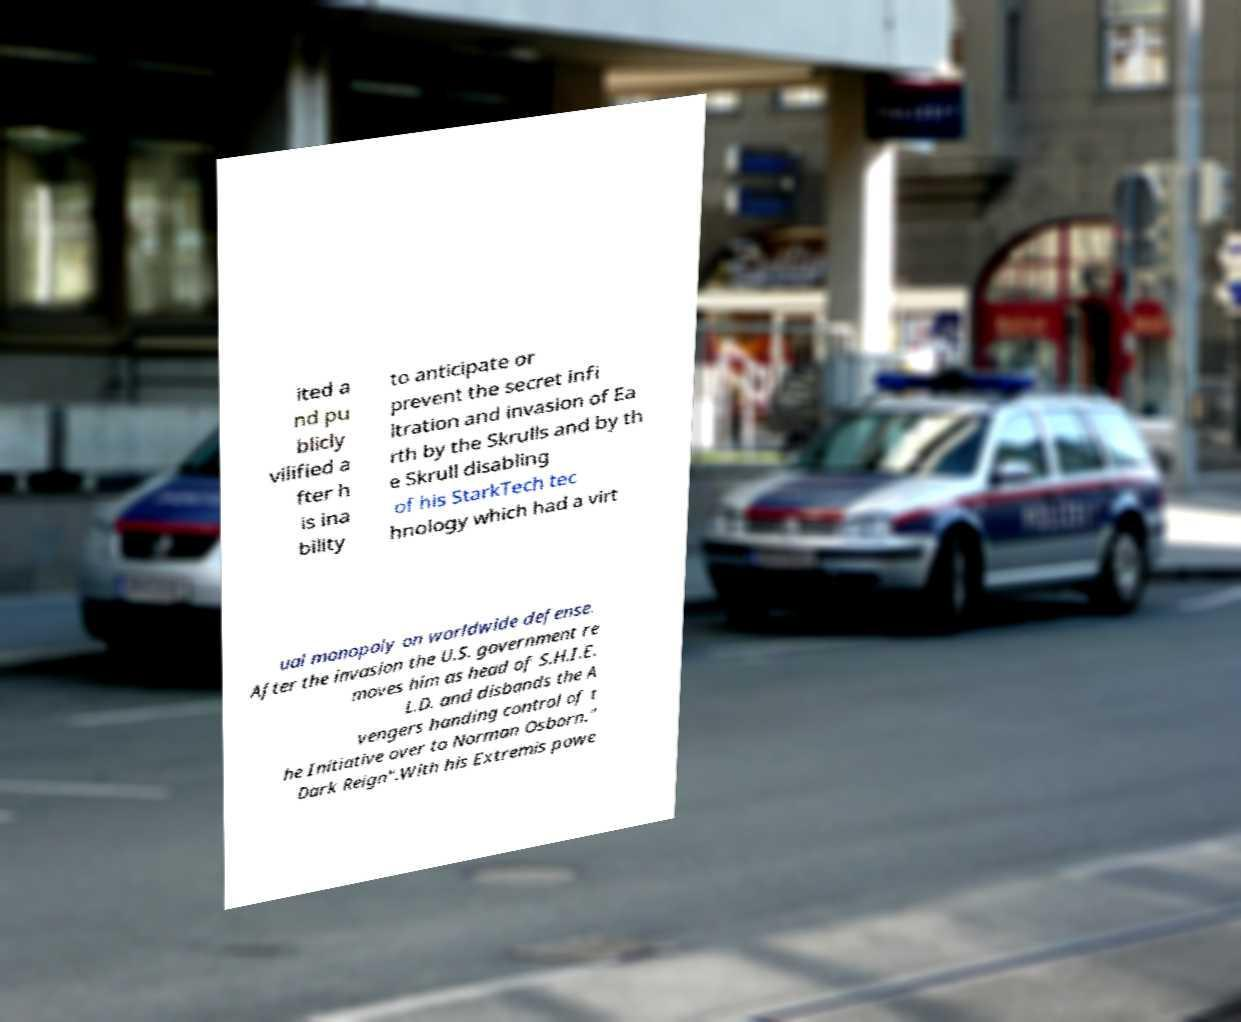I need the written content from this picture converted into text. Can you do that? ited a nd pu blicly vilified a fter h is ina bility to anticipate or prevent the secret infi ltration and invasion of Ea rth by the Skrulls and by th e Skrull disabling of his StarkTech tec hnology which had a virt ual monopoly on worldwide defense. After the invasion the U.S. government re moves him as head of S.H.I.E. L.D. and disbands the A vengers handing control of t he Initiative over to Norman Osborn." Dark Reign".With his Extremis powe 